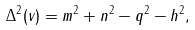Convert formula to latex. <formula><loc_0><loc_0><loc_500><loc_500>\Delta ^ { 2 } ( v ) = m ^ { 2 } + n ^ { 2 } - q ^ { 2 } - h ^ { 2 } ,</formula> 